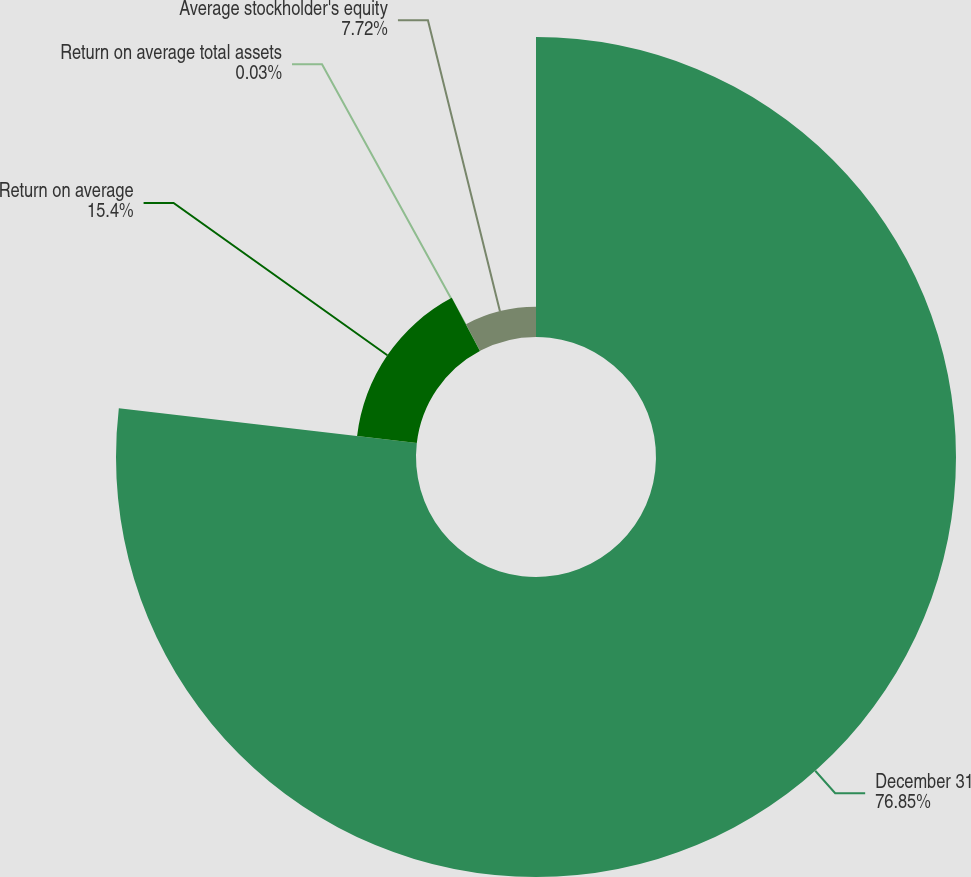Convert chart to OTSL. <chart><loc_0><loc_0><loc_500><loc_500><pie_chart><fcel>December 31<fcel>Return on average<fcel>Return on average total assets<fcel>Average stockholder's equity<nl><fcel>76.85%<fcel>15.4%<fcel>0.03%<fcel>7.72%<nl></chart> 